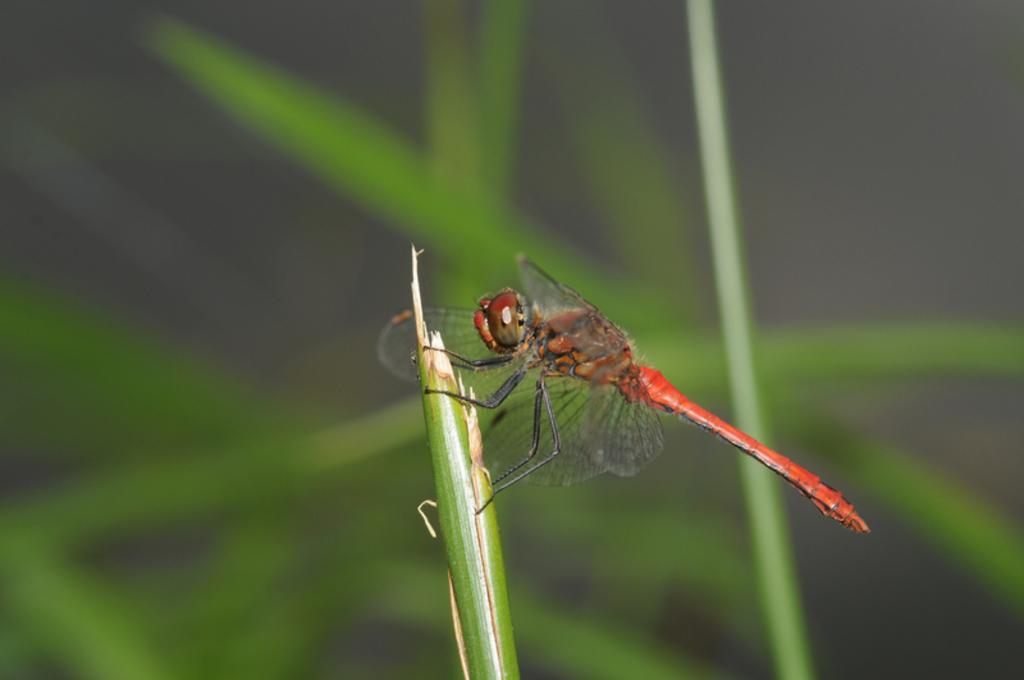What insect can be seen in the image? There is a dragonfly in the image. Where is the dragonfly located? The dragonfly is on a leaf. What else can be seen in the background of the image? There are more leaves visible in the background. How would you describe the background of the image? The background is blurred. How many horses can be seen in the image? There are no horses present in the image; it features a dragonfly on a leaf. What type of owl is perched on the leaf with the dragonfly? There is no owl present in the image; only the dragonfly and leaves are visible. 